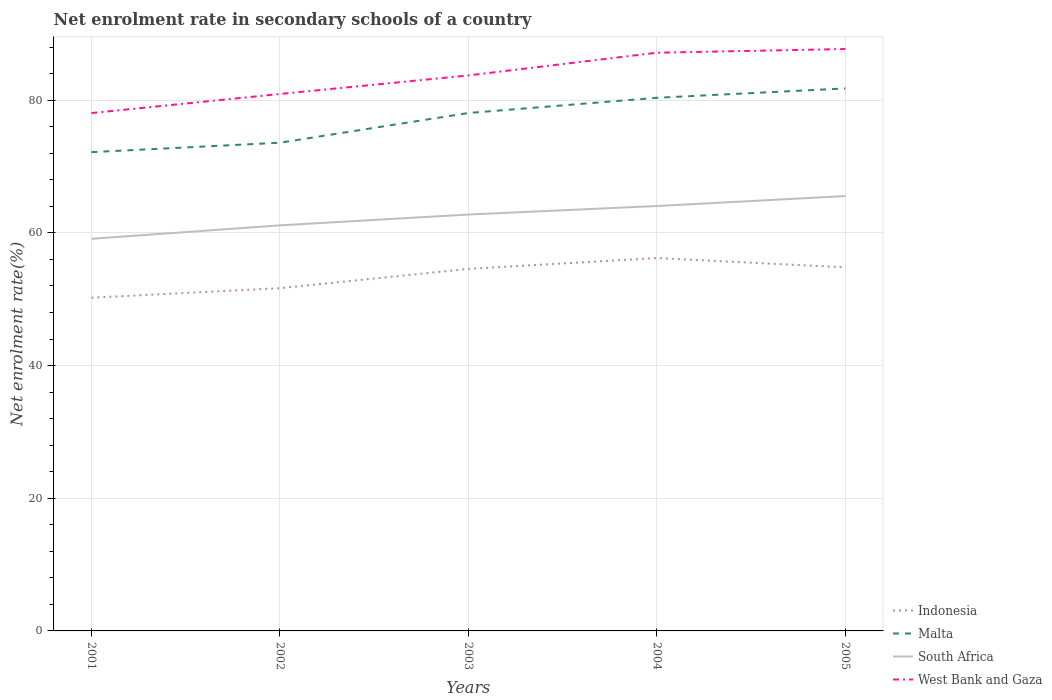How many different coloured lines are there?
Ensure brevity in your answer.  4. Across all years, what is the maximum net enrolment rate in secondary schools in Malta?
Your answer should be compact. 72.17. In which year was the net enrolment rate in secondary schools in Indonesia maximum?
Ensure brevity in your answer.  2001. What is the total net enrolment rate in secondary schools in Indonesia in the graph?
Make the answer very short. -0.23. What is the difference between the highest and the second highest net enrolment rate in secondary schools in West Bank and Gaza?
Offer a terse response. 9.66. What is the difference between the highest and the lowest net enrolment rate in secondary schools in Indonesia?
Keep it short and to the point. 3. How many lines are there?
Your response must be concise. 4. Does the graph contain any zero values?
Offer a terse response. No. What is the title of the graph?
Provide a succinct answer. Net enrolment rate in secondary schools of a country. What is the label or title of the Y-axis?
Offer a very short reply. Net enrolment rate(%). What is the Net enrolment rate(%) in Indonesia in 2001?
Keep it short and to the point. 50.24. What is the Net enrolment rate(%) in Malta in 2001?
Your response must be concise. 72.17. What is the Net enrolment rate(%) of South Africa in 2001?
Provide a succinct answer. 59.11. What is the Net enrolment rate(%) in West Bank and Gaza in 2001?
Offer a terse response. 78.06. What is the Net enrolment rate(%) of Indonesia in 2002?
Give a very brief answer. 51.66. What is the Net enrolment rate(%) of Malta in 2002?
Give a very brief answer. 73.6. What is the Net enrolment rate(%) in South Africa in 2002?
Your answer should be very brief. 61.14. What is the Net enrolment rate(%) of West Bank and Gaza in 2002?
Offer a terse response. 80.94. What is the Net enrolment rate(%) in Indonesia in 2003?
Provide a short and direct response. 54.58. What is the Net enrolment rate(%) of Malta in 2003?
Provide a succinct answer. 78.08. What is the Net enrolment rate(%) in South Africa in 2003?
Offer a very short reply. 62.77. What is the Net enrolment rate(%) of West Bank and Gaza in 2003?
Your answer should be very brief. 83.74. What is the Net enrolment rate(%) of Indonesia in 2004?
Provide a succinct answer. 56.21. What is the Net enrolment rate(%) of Malta in 2004?
Ensure brevity in your answer.  80.37. What is the Net enrolment rate(%) in South Africa in 2004?
Your response must be concise. 64.05. What is the Net enrolment rate(%) of West Bank and Gaza in 2004?
Your answer should be compact. 87.16. What is the Net enrolment rate(%) of Indonesia in 2005?
Provide a short and direct response. 54.8. What is the Net enrolment rate(%) in Malta in 2005?
Offer a terse response. 81.78. What is the Net enrolment rate(%) of South Africa in 2005?
Give a very brief answer. 65.55. What is the Net enrolment rate(%) of West Bank and Gaza in 2005?
Provide a short and direct response. 87.72. Across all years, what is the maximum Net enrolment rate(%) of Indonesia?
Provide a succinct answer. 56.21. Across all years, what is the maximum Net enrolment rate(%) in Malta?
Make the answer very short. 81.78. Across all years, what is the maximum Net enrolment rate(%) of South Africa?
Provide a succinct answer. 65.55. Across all years, what is the maximum Net enrolment rate(%) of West Bank and Gaza?
Provide a succinct answer. 87.72. Across all years, what is the minimum Net enrolment rate(%) in Indonesia?
Provide a short and direct response. 50.24. Across all years, what is the minimum Net enrolment rate(%) of Malta?
Ensure brevity in your answer.  72.17. Across all years, what is the minimum Net enrolment rate(%) of South Africa?
Provide a succinct answer. 59.11. Across all years, what is the minimum Net enrolment rate(%) of West Bank and Gaza?
Offer a terse response. 78.06. What is the total Net enrolment rate(%) in Indonesia in the graph?
Provide a succinct answer. 267.49. What is the total Net enrolment rate(%) of Malta in the graph?
Provide a succinct answer. 385.99. What is the total Net enrolment rate(%) in South Africa in the graph?
Offer a terse response. 312.62. What is the total Net enrolment rate(%) of West Bank and Gaza in the graph?
Your answer should be very brief. 417.62. What is the difference between the Net enrolment rate(%) in Indonesia in 2001 and that in 2002?
Offer a very short reply. -1.43. What is the difference between the Net enrolment rate(%) in Malta in 2001 and that in 2002?
Your response must be concise. -1.42. What is the difference between the Net enrolment rate(%) in South Africa in 2001 and that in 2002?
Your response must be concise. -2.02. What is the difference between the Net enrolment rate(%) in West Bank and Gaza in 2001 and that in 2002?
Ensure brevity in your answer.  -2.88. What is the difference between the Net enrolment rate(%) in Indonesia in 2001 and that in 2003?
Offer a terse response. -4.34. What is the difference between the Net enrolment rate(%) in Malta in 2001 and that in 2003?
Provide a succinct answer. -5.9. What is the difference between the Net enrolment rate(%) of South Africa in 2001 and that in 2003?
Offer a very short reply. -3.66. What is the difference between the Net enrolment rate(%) of West Bank and Gaza in 2001 and that in 2003?
Your answer should be very brief. -5.67. What is the difference between the Net enrolment rate(%) of Indonesia in 2001 and that in 2004?
Your response must be concise. -5.98. What is the difference between the Net enrolment rate(%) of Malta in 2001 and that in 2004?
Make the answer very short. -8.19. What is the difference between the Net enrolment rate(%) in South Africa in 2001 and that in 2004?
Your response must be concise. -4.94. What is the difference between the Net enrolment rate(%) of West Bank and Gaza in 2001 and that in 2004?
Your response must be concise. -9.1. What is the difference between the Net enrolment rate(%) of Indonesia in 2001 and that in 2005?
Make the answer very short. -4.57. What is the difference between the Net enrolment rate(%) of Malta in 2001 and that in 2005?
Your response must be concise. -9.6. What is the difference between the Net enrolment rate(%) in South Africa in 2001 and that in 2005?
Give a very brief answer. -6.44. What is the difference between the Net enrolment rate(%) in West Bank and Gaza in 2001 and that in 2005?
Make the answer very short. -9.66. What is the difference between the Net enrolment rate(%) in Indonesia in 2002 and that in 2003?
Your response must be concise. -2.91. What is the difference between the Net enrolment rate(%) in Malta in 2002 and that in 2003?
Provide a succinct answer. -4.48. What is the difference between the Net enrolment rate(%) of South Africa in 2002 and that in 2003?
Offer a very short reply. -1.63. What is the difference between the Net enrolment rate(%) in West Bank and Gaza in 2002 and that in 2003?
Your answer should be very brief. -2.8. What is the difference between the Net enrolment rate(%) of Indonesia in 2002 and that in 2004?
Provide a succinct answer. -4.55. What is the difference between the Net enrolment rate(%) in Malta in 2002 and that in 2004?
Provide a short and direct response. -6.77. What is the difference between the Net enrolment rate(%) in South Africa in 2002 and that in 2004?
Provide a succinct answer. -2.92. What is the difference between the Net enrolment rate(%) in West Bank and Gaza in 2002 and that in 2004?
Offer a terse response. -6.22. What is the difference between the Net enrolment rate(%) of Indonesia in 2002 and that in 2005?
Your answer should be very brief. -3.14. What is the difference between the Net enrolment rate(%) in Malta in 2002 and that in 2005?
Offer a very short reply. -8.18. What is the difference between the Net enrolment rate(%) of South Africa in 2002 and that in 2005?
Provide a succinct answer. -4.42. What is the difference between the Net enrolment rate(%) of West Bank and Gaza in 2002 and that in 2005?
Provide a succinct answer. -6.78. What is the difference between the Net enrolment rate(%) in Indonesia in 2003 and that in 2004?
Your answer should be very brief. -1.64. What is the difference between the Net enrolment rate(%) in Malta in 2003 and that in 2004?
Offer a very short reply. -2.29. What is the difference between the Net enrolment rate(%) of South Africa in 2003 and that in 2004?
Your answer should be very brief. -1.28. What is the difference between the Net enrolment rate(%) in West Bank and Gaza in 2003 and that in 2004?
Your answer should be compact. -3.42. What is the difference between the Net enrolment rate(%) of Indonesia in 2003 and that in 2005?
Keep it short and to the point. -0.23. What is the difference between the Net enrolment rate(%) of Malta in 2003 and that in 2005?
Make the answer very short. -3.7. What is the difference between the Net enrolment rate(%) in South Africa in 2003 and that in 2005?
Offer a very short reply. -2.78. What is the difference between the Net enrolment rate(%) in West Bank and Gaza in 2003 and that in 2005?
Your answer should be compact. -3.98. What is the difference between the Net enrolment rate(%) of Indonesia in 2004 and that in 2005?
Offer a very short reply. 1.41. What is the difference between the Net enrolment rate(%) of Malta in 2004 and that in 2005?
Make the answer very short. -1.41. What is the difference between the Net enrolment rate(%) of South Africa in 2004 and that in 2005?
Your answer should be very brief. -1.5. What is the difference between the Net enrolment rate(%) of West Bank and Gaza in 2004 and that in 2005?
Your answer should be compact. -0.56. What is the difference between the Net enrolment rate(%) of Indonesia in 2001 and the Net enrolment rate(%) of Malta in 2002?
Provide a succinct answer. -23.36. What is the difference between the Net enrolment rate(%) in Indonesia in 2001 and the Net enrolment rate(%) in South Africa in 2002?
Provide a short and direct response. -10.9. What is the difference between the Net enrolment rate(%) in Indonesia in 2001 and the Net enrolment rate(%) in West Bank and Gaza in 2002?
Your answer should be compact. -30.7. What is the difference between the Net enrolment rate(%) of Malta in 2001 and the Net enrolment rate(%) of South Africa in 2002?
Your answer should be compact. 11.04. What is the difference between the Net enrolment rate(%) of Malta in 2001 and the Net enrolment rate(%) of West Bank and Gaza in 2002?
Make the answer very short. -8.76. What is the difference between the Net enrolment rate(%) of South Africa in 2001 and the Net enrolment rate(%) of West Bank and Gaza in 2002?
Provide a short and direct response. -21.83. What is the difference between the Net enrolment rate(%) of Indonesia in 2001 and the Net enrolment rate(%) of Malta in 2003?
Your answer should be very brief. -27.84. What is the difference between the Net enrolment rate(%) in Indonesia in 2001 and the Net enrolment rate(%) in South Africa in 2003?
Provide a short and direct response. -12.53. What is the difference between the Net enrolment rate(%) of Indonesia in 2001 and the Net enrolment rate(%) of West Bank and Gaza in 2003?
Give a very brief answer. -33.5. What is the difference between the Net enrolment rate(%) in Malta in 2001 and the Net enrolment rate(%) in South Africa in 2003?
Ensure brevity in your answer.  9.4. What is the difference between the Net enrolment rate(%) of Malta in 2001 and the Net enrolment rate(%) of West Bank and Gaza in 2003?
Keep it short and to the point. -11.56. What is the difference between the Net enrolment rate(%) of South Africa in 2001 and the Net enrolment rate(%) of West Bank and Gaza in 2003?
Your answer should be very brief. -24.63. What is the difference between the Net enrolment rate(%) of Indonesia in 2001 and the Net enrolment rate(%) of Malta in 2004?
Provide a succinct answer. -30.13. What is the difference between the Net enrolment rate(%) of Indonesia in 2001 and the Net enrolment rate(%) of South Africa in 2004?
Provide a short and direct response. -13.82. What is the difference between the Net enrolment rate(%) in Indonesia in 2001 and the Net enrolment rate(%) in West Bank and Gaza in 2004?
Provide a short and direct response. -36.93. What is the difference between the Net enrolment rate(%) of Malta in 2001 and the Net enrolment rate(%) of South Africa in 2004?
Make the answer very short. 8.12. What is the difference between the Net enrolment rate(%) of Malta in 2001 and the Net enrolment rate(%) of West Bank and Gaza in 2004?
Keep it short and to the point. -14.99. What is the difference between the Net enrolment rate(%) of South Africa in 2001 and the Net enrolment rate(%) of West Bank and Gaza in 2004?
Your answer should be very brief. -28.05. What is the difference between the Net enrolment rate(%) of Indonesia in 2001 and the Net enrolment rate(%) of Malta in 2005?
Your response must be concise. -31.54. What is the difference between the Net enrolment rate(%) in Indonesia in 2001 and the Net enrolment rate(%) in South Africa in 2005?
Offer a terse response. -15.32. What is the difference between the Net enrolment rate(%) in Indonesia in 2001 and the Net enrolment rate(%) in West Bank and Gaza in 2005?
Ensure brevity in your answer.  -37.49. What is the difference between the Net enrolment rate(%) in Malta in 2001 and the Net enrolment rate(%) in South Africa in 2005?
Provide a succinct answer. 6.62. What is the difference between the Net enrolment rate(%) of Malta in 2001 and the Net enrolment rate(%) of West Bank and Gaza in 2005?
Your answer should be compact. -15.55. What is the difference between the Net enrolment rate(%) of South Africa in 2001 and the Net enrolment rate(%) of West Bank and Gaza in 2005?
Give a very brief answer. -28.61. What is the difference between the Net enrolment rate(%) in Indonesia in 2002 and the Net enrolment rate(%) in Malta in 2003?
Make the answer very short. -26.41. What is the difference between the Net enrolment rate(%) in Indonesia in 2002 and the Net enrolment rate(%) in South Africa in 2003?
Ensure brevity in your answer.  -11.1. What is the difference between the Net enrolment rate(%) in Indonesia in 2002 and the Net enrolment rate(%) in West Bank and Gaza in 2003?
Keep it short and to the point. -32.07. What is the difference between the Net enrolment rate(%) in Malta in 2002 and the Net enrolment rate(%) in South Africa in 2003?
Make the answer very short. 10.83. What is the difference between the Net enrolment rate(%) in Malta in 2002 and the Net enrolment rate(%) in West Bank and Gaza in 2003?
Provide a succinct answer. -10.14. What is the difference between the Net enrolment rate(%) in South Africa in 2002 and the Net enrolment rate(%) in West Bank and Gaza in 2003?
Offer a terse response. -22.6. What is the difference between the Net enrolment rate(%) of Indonesia in 2002 and the Net enrolment rate(%) of Malta in 2004?
Ensure brevity in your answer.  -28.7. What is the difference between the Net enrolment rate(%) of Indonesia in 2002 and the Net enrolment rate(%) of South Africa in 2004?
Your answer should be very brief. -12.39. What is the difference between the Net enrolment rate(%) in Indonesia in 2002 and the Net enrolment rate(%) in West Bank and Gaza in 2004?
Make the answer very short. -35.5. What is the difference between the Net enrolment rate(%) in Malta in 2002 and the Net enrolment rate(%) in South Africa in 2004?
Your answer should be compact. 9.54. What is the difference between the Net enrolment rate(%) of Malta in 2002 and the Net enrolment rate(%) of West Bank and Gaza in 2004?
Your answer should be compact. -13.57. What is the difference between the Net enrolment rate(%) of South Africa in 2002 and the Net enrolment rate(%) of West Bank and Gaza in 2004?
Your answer should be very brief. -26.02. What is the difference between the Net enrolment rate(%) in Indonesia in 2002 and the Net enrolment rate(%) in Malta in 2005?
Ensure brevity in your answer.  -30.11. What is the difference between the Net enrolment rate(%) in Indonesia in 2002 and the Net enrolment rate(%) in South Africa in 2005?
Your answer should be very brief. -13.89. What is the difference between the Net enrolment rate(%) in Indonesia in 2002 and the Net enrolment rate(%) in West Bank and Gaza in 2005?
Provide a succinct answer. -36.06. What is the difference between the Net enrolment rate(%) in Malta in 2002 and the Net enrolment rate(%) in South Africa in 2005?
Your answer should be very brief. 8.04. What is the difference between the Net enrolment rate(%) of Malta in 2002 and the Net enrolment rate(%) of West Bank and Gaza in 2005?
Ensure brevity in your answer.  -14.13. What is the difference between the Net enrolment rate(%) in South Africa in 2002 and the Net enrolment rate(%) in West Bank and Gaza in 2005?
Your answer should be compact. -26.58. What is the difference between the Net enrolment rate(%) of Indonesia in 2003 and the Net enrolment rate(%) of Malta in 2004?
Provide a succinct answer. -25.79. What is the difference between the Net enrolment rate(%) in Indonesia in 2003 and the Net enrolment rate(%) in South Africa in 2004?
Your answer should be compact. -9.48. What is the difference between the Net enrolment rate(%) in Indonesia in 2003 and the Net enrolment rate(%) in West Bank and Gaza in 2004?
Offer a very short reply. -32.58. What is the difference between the Net enrolment rate(%) in Malta in 2003 and the Net enrolment rate(%) in South Africa in 2004?
Give a very brief answer. 14.02. What is the difference between the Net enrolment rate(%) of Malta in 2003 and the Net enrolment rate(%) of West Bank and Gaza in 2004?
Offer a terse response. -9.09. What is the difference between the Net enrolment rate(%) of South Africa in 2003 and the Net enrolment rate(%) of West Bank and Gaza in 2004?
Give a very brief answer. -24.39. What is the difference between the Net enrolment rate(%) of Indonesia in 2003 and the Net enrolment rate(%) of Malta in 2005?
Ensure brevity in your answer.  -27.2. What is the difference between the Net enrolment rate(%) in Indonesia in 2003 and the Net enrolment rate(%) in South Africa in 2005?
Keep it short and to the point. -10.98. What is the difference between the Net enrolment rate(%) in Indonesia in 2003 and the Net enrolment rate(%) in West Bank and Gaza in 2005?
Keep it short and to the point. -33.14. What is the difference between the Net enrolment rate(%) of Malta in 2003 and the Net enrolment rate(%) of South Africa in 2005?
Your answer should be compact. 12.52. What is the difference between the Net enrolment rate(%) in Malta in 2003 and the Net enrolment rate(%) in West Bank and Gaza in 2005?
Keep it short and to the point. -9.65. What is the difference between the Net enrolment rate(%) of South Africa in 2003 and the Net enrolment rate(%) of West Bank and Gaza in 2005?
Ensure brevity in your answer.  -24.95. What is the difference between the Net enrolment rate(%) in Indonesia in 2004 and the Net enrolment rate(%) in Malta in 2005?
Your answer should be compact. -25.57. What is the difference between the Net enrolment rate(%) in Indonesia in 2004 and the Net enrolment rate(%) in South Africa in 2005?
Offer a very short reply. -9.34. What is the difference between the Net enrolment rate(%) of Indonesia in 2004 and the Net enrolment rate(%) of West Bank and Gaza in 2005?
Your answer should be compact. -31.51. What is the difference between the Net enrolment rate(%) of Malta in 2004 and the Net enrolment rate(%) of South Africa in 2005?
Offer a terse response. 14.82. What is the difference between the Net enrolment rate(%) in Malta in 2004 and the Net enrolment rate(%) in West Bank and Gaza in 2005?
Your answer should be compact. -7.35. What is the difference between the Net enrolment rate(%) of South Africa in 2004 and the Net enrolment rate(%) of West Bank and Gaza in 2005?
Give a very brief answer. -23.67. What is the average Net enrolment rate(%) in Indonesia per year?
Offer a very short reply. 53.5. What is the average Net enrolment rate(%) of Malta per year?
Make the answer very short. 77.2. What is the average Net enrolment rate(%) in South Africa per year?
Your answer should be compact. 62.52. What is the average Net enrolment rate(%) in West Bank and Gaza per year?
Provide a succinct answer. 83.52. In the year 2001, what is the difference between the Net enrolment rate(%) of Indonesia and Net enrolment rate(%) of Malta?
Offer a very short reply. -21.94. In the year 2001, what is the difference between the Net enrolment rate(%) of Indonesia and Net enrolment rate(%) of South Africa?
Your answer should be compact. -8.88. In the year 2001, what is the difference between the Net enrolment rate(%) in Indonesia and Net enrolment rate(%) in West Bank and Gaza?
Your answer should be very brief. -27.83. In the year 2001, what is the difference between the Net enrolment rate(%) in Malta and Net enrolment rate(%) in South Africa?
Ensure brevity in your answer.  13.06. In the year 2001, what is the difference between the Net enrolment rate(%) of Malta and Net enrolment rate(%) of West Bank and Gaza?
Give a very brief answer. -5.89. In the year 2001, what is the difference between the Net enrolment rate(%) of South Africa and Net enrolment rate(%) of West Bank and Gaza?
Provide a short and direct response. -18.95. In the year 2002, what is the difference between the Net enrolment rate(%) of Indonesia and Net enrolment rate(%) of Malta?
Ensure brevity in your answer.  -21.93. In the year 2002, what is the difference between the Net enrolment rate(%) in Indonesia and Net enrolment rate(%) in South Africa?
Ensure brevity in your answer.  -9.47. In the year 2002, what is the difference between the Net enrolment rate(%) in Indonesia and Net enrolment rate(%) in West Bank and Gaza?
Provide a short and direct response. -29.27. In the year 2002, what is the difference between the Net enrolment rate(%) of Malta and Net enrolment rate(%) of South Africa?
Your answer should be very brief. 12.46. In the year 2002, what is the difference between the Net enrolment rate(%) of Malta and Net enrolment rate(%) of West Bank and Gaza?
Keep it short and to the point. -7.34. In the year 2002, what is the difference between the Net enrolment rate(%) in South Africa and Net enrolment rate(%) in West Bank and Gaza?
Your response must be concise. -19.8. In the year 2003, what is the difference between the Net enrolment rate(%) of Indonesia and Net enrolment rate(%) of Malta?
Your answer should be compact. -23.5. In the year 2003, what is the difference between the Net enrolment rate(%) in Indonesia and Net enrolment rate(%) in South Africa?
Ensure brevity in your answer.  -8.19. In the year 2003, what is the difference between the Net enrolment rate(%) in Indonesia and Net enrolment rate(%) in West Bank and Gaza?
Your response must be concise. -29.16. In the year 2003, what is the difference between the Net enrolment rate(%) of Malta and Net enrolment rate(%) of South Africa?
Your answer should be compact. 15.31. In the year 2003, what is the difference between the Net enrolment rate(%) in Malta and Net enrolment rate(%) in West Bank and Gaza?
Give a very brief answer. -5.66. In the year 2003, what is the difference between the Net enrolment rate(%) of South Africa and Net enrolment rate(%) of West Bank and Gaza?
Ensure brevity in your answer.  -20.97. In the year 2004, what is the difference between the Net enrolment rate(%) in Indonesia and Net enrolment rate(%) in Malta?
Keep it short and to the point. -24.16. In the year 2004, what is the difference between the Net enrolment rate(%) of Indonesia and Net enrolment rate(%) of South Africa?
Provide a short and direct response. -7.84. In the year 2004, what is the difference between the Net enrolment rate(%) of Indonesia and Net enrolment rate(%) of West Bank and Gaza?
Provide a short and direct response. -30.95. In the year 2004, what is the difference between the Net enrolment rate(%) in Malta and Net enrolment rate(%) in South Africa?
Give a very brief answer. 16.32. In the year 2004, what is the difference between the Net enrolment rate(%) of Malta and Net enrolment rate(%) of West Bank and Gaza?
Make the answer very short. -6.79. In the year 2004, what is the difference between the Net enrolment rate(%) of South Africa and Net enrolment rate(%) of West Bank and Gaza?
Provide a short and direct response. -23.11. In the year 2005, what is the difference between the Net enrolment rate(%) in Indonesia and Net enrolment rate(%) in Malta?
Offer a very short reply. -26.98. In the year 2005, what is the difference between the Net enrolment rate(%) in Indonesia and Net enrolment rate(%) in South Africa?
Provide a short and direct response. -10.75. In the year 2005, what is the difference between the Net enrolment rate(%) in Indonesia and Net enrolment rate(%) in West Bank and Gaza?
Your answer should be compact. -32.92. In the year 2005, what is the difference between the Net enrolment rate(%) of Malta and Net enrolment rate(%) of South Africa?
Your response must be concise. 16.23. In the year 2005, what is the difference between the Net enrolment rate(%) of Malta and Net enrolment rate(%) of West Bank and Gaza?
Your response must be concise. -5.94. In the year 2005, what is the difference between the Net enrolment rate(%) in South Africa and Net enrolment rate(%) in West Bank and Gaza?
Your response must be concise. -22.17. What is the ratio of the Net enrolment rate(%) of Indonesia in 2001 to that in 2002?
Provide a short and direct response. 0.97. What is the ratio of the Net enrolment rate(%) of Malta in 2001 to that in 2002?
Provide a short and direct response. 0.98. What is the ratio of the Net enrolment rate(%) of South Africa in 2001 to that in 2002?
Provide a short and direct response. 0.97. What is the ratio of the Net enrolment rate(%) in West Bank and Gaza in 2001 to that in 2002?
Offer a terse response. 0.96. What is the ratio of the Net enrolment rate(%) in Indonesia in 2001 to that in 2003?
Your answer should be very brief. 0.92. What is the ratio of the Net enrolment rate(%) in Malta in 2001 to that in 2003?
Make the answer very short. 0.92. What is the ratio of the Net enrolment rate(%) in South Africa in 2001 to that in 2003?
Give a very brief answer. 0.94. What is the ratio of the Net enrolment rate(%) of West Bank and Gaza in 2001 to that in 2003?
Make the answer very short. 0.93. What is the ratio of the Net enrolment rate(%) in Indonesia in 2001 to that in 2004?
Provide a short and direct response. 0.89. What is the ratio of the Net enrolment rate(%) in Malta in 2001 to that in 2004?
Your answer should be compact. 0.9. What is the ratio of the Net enrolment rate(%) of South Africa in 2001 to that in 2004?
Provide a succinct answer. 0.92. What is the ratio of the Net enrolment rate(%) of West Bank and Gaza in 2001 to that in 2004?
Your response must be concise. 0.9. What is the ratio of the Net enrolment rate(%) of Indonesia in 2001 to that in 2005?
Your response must be concise. 0.92. What is the ratio of the Net enrolment rate(%) of Malta in 2001 to that in 2005?
Offer a very short reply. 0.88. What is the ratio of the Net enrolment rate(%) of South Africa in 2001 to that in 2005?
Give a very brief answer. 0.9. What is the ratio of the Net enrolment rate(%) in West Bank and Gaza in 2001 to that in 2005?
Offer a very short reply. 0.89. What is the ratio of the Net enrolment rate(%) in Indonesia in 2002 to that in 2003?
Offer a terse response. 0.95. What is the ratio of the Net enrolment rate(%) in Malta in 2002 to that in 2003?
Make the answer very short. 0.94. What is the ratio of the Net enrolment rate(%) in South Africa in 2002 to that in 2003?
Your response must be concise. 0.97. What is the ratio of the Net enrolment rate(%) of West Bank and Gaza in 2002 to that in 2003?
Keep it short and to the point. 0.97. What is the ratio of the Net enrolment rate(%) of Indonesia in 2002 to that in 2004?
Your answer should be compact. 0.92. What is the ratio of the Net enrolment rate(%) in Malta in 2002 to that in 2004?
Your answer should be compact. 0.92. What is the ratio of the Net enrolment rate(%) of South Africa in 2002 to that in 2004?
Ensure brevity in your answer.  0.95. What is the ratio of the Net enrolment rate(%) in West Bank and Gaza in 2002 to that in 2004?
Provide a succinct answer. 0.93. What is the ratio of the Net enrolment rate(%) in Indonesia in 2002 to that in 2005?
Ensure brevity in your answer.  0.94. What is the ratio of the Net enrolment rate(%) of Malta in 2002 to that in 2005?
Provide a succinct answer. 0.9. What is the ratio of the Net enrolment rate(%) in South Africa in 2002 to that in 2005?
Your response must be concise. 0.93. What is the ratio of the Net enrolment rate(%) in West Bank and Gaza in 2002 to that in 2005?
Provide a succinct answer. 0.92. What is the ratio of the Net enrolment rate(%) in Indonesia in 2003 to that in 2004?
Offer a terse response. 0.97. What is the ratio of the Net enrolment rate(%) of Malta in 2003 to that in 2004?
Your answer should be very brief. 0.97. What is the ratio of the Net enrolment rate(%) of South Africa in 2003 to that in 2004?
Give a very brief answer. 0.98. What is the ratio of the Net enrolment rate(%) of West Bank and Gaza in 2003 to that in 2004?
Provide a short and direct response. 0.96. What is the ratio of the Net enrolment rate(%) of Indonesia in 2003 to that in 2005?
Ensure brevity in your answer.  1. What is the ratio of the Net enrolment rate(%) in Malta in 2003 to that in 2005?
Keep it short and to the point. 0.95. What is the ratio of the Net enrolment rate(%) in South Africa in 2003 to that in 2005?
Give a very brief answer. 0.96. What is the ratio of the Net enrolment rate(%) of West Bank and Gaza in 2003 to that in 2005?
Offer a terse response. 0.95. What is the ratio of the Net enrolment rate(%) in Indonesia in 2004 to that in 2005?
Give a very brief answer. 1.03. What is the ratio of the Net enrolment rate(%) in Malta in 2004 to that in 2005?
Give a very brief answer. 0.98. What is the ratio of the Net enrolment rate(%) of South Africa in 2004 to that in 2005?
Provide a succinct answer. 0.98. What is the difference between the highest and the second highest Net enrolment rate(%) in Indonesia?
Keep it short and to the point. 1.41. What is the difference between the highest and the second highest Net enrolment rate(%) of Malta?
Your response must be concise. 1.41. What is the difference between the highest and the second highest Net enrolment rate(%) in West Bank and Gaza?
Provide a succinct answer. 0.56. What is the difference between the highest and the lowest Net enrolment rate(%) of Indonesia?
Keep it short and to the point. 5.98. What is the difference between the highest and the lowest Net enrolment rate(%) in Malta?
Offer a terse response. 9.6. What is the difference between the highest and the lowest Net enrolment rate(%) in South Africa?
Your answer should be very brief. 6.44. What is the difference between the highest and the lowest Net enrolment rate(%) in West Bank and Gaza?
Provide a short and direct response. 9.66. 